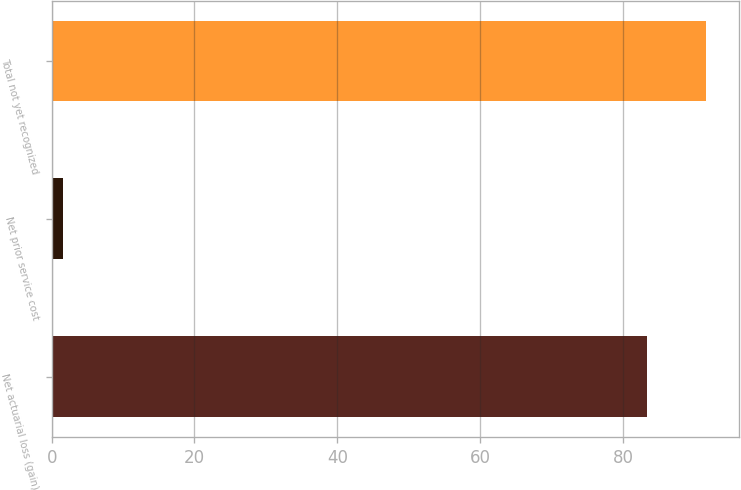Convert chart. <chart><loc_0><loc_0><loc_500><loc_500><bar_chart><fcel>Net actuarial loss (gain)<fcel>Net prior service cost<fcel>Total not yet recognized<nl><fcel>83.3<fcel>1.6<fcel>91.63<nl></chart> 